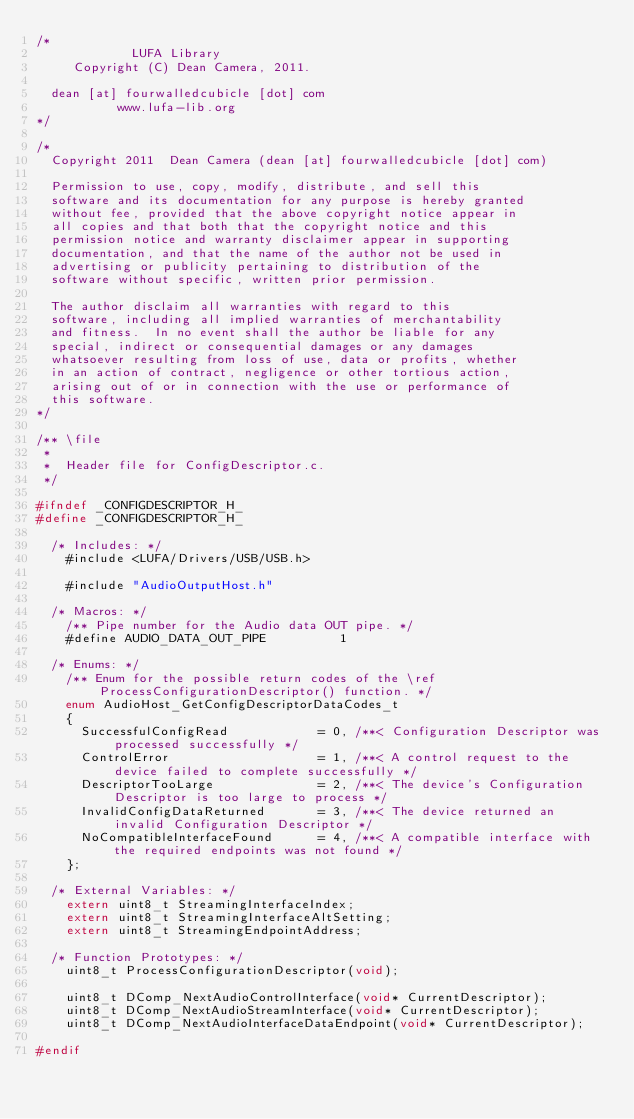Convert code to text. <code><loc_0><loc_0><loc_500><loc_500><_C_>/*
             LUFA Library
     Copyright (C) Dean Camera, 2011.

  dean [at] fourwalledcubicle [dot] com
           www.lufa-lib.org
*/

/*
  Copyright 2011  Dean Camera (dean [at] fourwalledcubicle [dot] com)

  Permission to use, copy, modify, distribute, and sell this
  software and its documentation for any purpose is hereby granted
  without fee, provided that the above copyright notice appear in
  all copies and that both that the copyright notice and this
  permission notice and warranty disclaimer appear in supporting
  documentation, and that the name of the author not be used in
  advertising or publicity pertaining to distribution of the
  software without specific, written prior permission.

  The author disclaim all warranties with regard to this
  software, including all implied warranties of merchantability
  and fitness.  In no event shall the author be liable for any
  special, indirect or consequential damages or any damages
  whatsoever resulting from loss of use, data or profits, whether
  in an action of contract, negligence or other tortious action,
  arising out of or in connection with the use or performance of
  this software.
*/

/** \file
 *
 *  Header file for ConfigDescriptor.c.
 */

#ifndef _CONFIGDESCRIPTOR_H_
#define _CONFIGDESCRIPTOR_H_

	/* Includes: */
		#include <LUFA/Drivers/USB/USB.h>

		#include "AudioOutputHost.h"

	/* Macros: */
		/** Pipe number for the Audio data OUT pipe. */
		#define AUDIO_DATA_OUT_PIPE          1

	/* Enums: */
		/** Enum for the possible return codes of the \ref ProcessConfigurationDescriptor() function. */
		enum AudioHost_GetConfigDescriptorDataCodes_t
		{
			SuccessfulConfigRead            = 0, /**< Configuration Descriptor was processed successfully */
			ControlError                    = 1, /**< A control request to the device failed to complete successfully */
			DescriptorTooLarge              = 2, /**< The device's Configuration Descriptor is too large to process */
			InvalidConfigDataReturned       = 3, /**< The device returned an invalid Configuration Descriptor */
			NoCompatibleInterfaceFound      = 4, /**< A compatible interface with the required endpoints was not found */
		};

	/* External Variables: */
		extern uint8_t StreamingInterfaceIndex;
		extern uint8_t StreamingInterfaceAltSetting;
		extern uint8_t StreamingEndpointAddress;

	/* Function Prototypes: */
		uint8_t ProcessConfigurationDescriptor(void);

		uint8_t DComp_NextAudioControlInterface(void* CurrentDescriptor);
		uint8_t DComp_NextAudioStreamInterface(void* CurrentDescriptor);
		uint8_t DComp_NextAudioInterfaceDataEndpoint(void* CurrentDescriptor);

#endif

</code> 